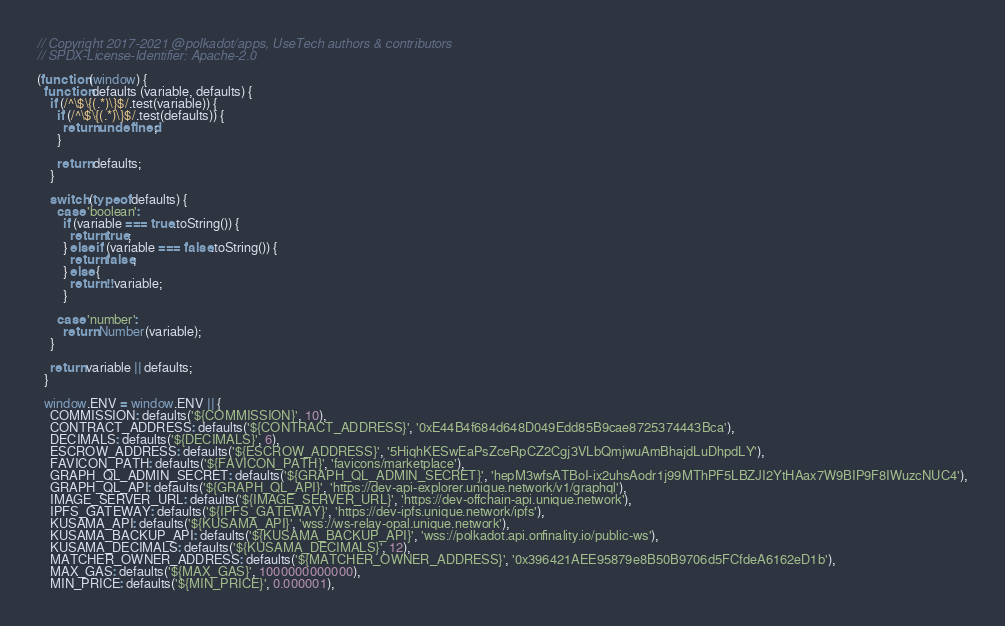<code> <loc_0><loc_0><loc_500><loc_500><_JavaScript_>// Copyright 2017-2021 @polkadot/apps, UseTech authors & contributors
// SPDX-License-Identifier: Apache-2.0

(function (window) {
  function defaults (variable, defaults) {
    if (/^\$\{(.*)\}$/.test(variable)) {
      if (/^\$\{(.*)\}$/.test(defaults)) {
        return undefined;
      }

      return defaults;
    }

    switch (typeof defaults) {
      case 'boolean':
        if (variable === true.toString()) {
          return true;
        } else if (variable === false.toString()) {
          return false;
        } else {
          return !!variable;
        }

      case 'number':
        return Number(variable);
    }

    return variable || defaults;
  }

  window.ENV = window.ENV || {
    COMMISSION: defaults('${COMMISSION}', 10),
    CONTRACT_ADDRESS: defaults('${CONTRACT_ADDRESS}', '0xE44B4f684d648D049Edd85B9cae8725374443Bca'),
    DECIMALS: defaults('${DECIMALS}', 6),
    ESCROW_ADDRESS: defaults('${ESCROW_ADDRESS}', '5HiqhKESwEaPsZceRpCZ2Cgj3VLbQmjwuAmBhajdLuDhpdLY'),
    FAVICON_PATH: defaults('${FAVICON_PATH}', 'favicons/marketplace'),
    GRAPH_QL_ADMIN_SECRET: defaults('${GRAPH_QL_ADMIN_SECRET}', 'hepM3wfsATBoI-ix2uhsAodr1j99MThPF5LBZJI2YtHAax7W9BIP9F8IWuzcNUC4'),
    GRAPH_QL_API: defaults('${GRAPH_QL_API}', 'https://dev-api-explorer.unique.network/v1/graphql'),
    IMAGE_SERVER_URL: defaults('${IMAGE_SERVER_URL}', 'https://dev-offchain-api.unique.network'),
    IPFS_GATEWAY: defaults('${IPFS_GATEWAY}', 'https://dev-ipfs.unique.network/ipfs'),
    KUSAMA_API: defaults('${KUSAMA_API}', 'wss://ws-relay-opal.unique.network'),
    KUSAMA_BACKUP_API: defaults('${KUSAMA_BACKUP_API}', 'wss://polkadot.api.onfinality.io/public-ws'),
    KUSAMA_DECIMALS: defaults('${KUSAMA_DECIMALS}', 12),
    MATCHER_OWNER_ADDRESS: defaults('${MATCHER_OWNER_ADDRESS}', '0x396421AEE95879e8B50B9706d5FCfdeA6162eD1b'),
    MAX_GAS: defaults('${MAX_GAS}', 1000000000000),
    MIN_PRICE: defaults('${MIN_PRICE}', 0.000001),</code> 